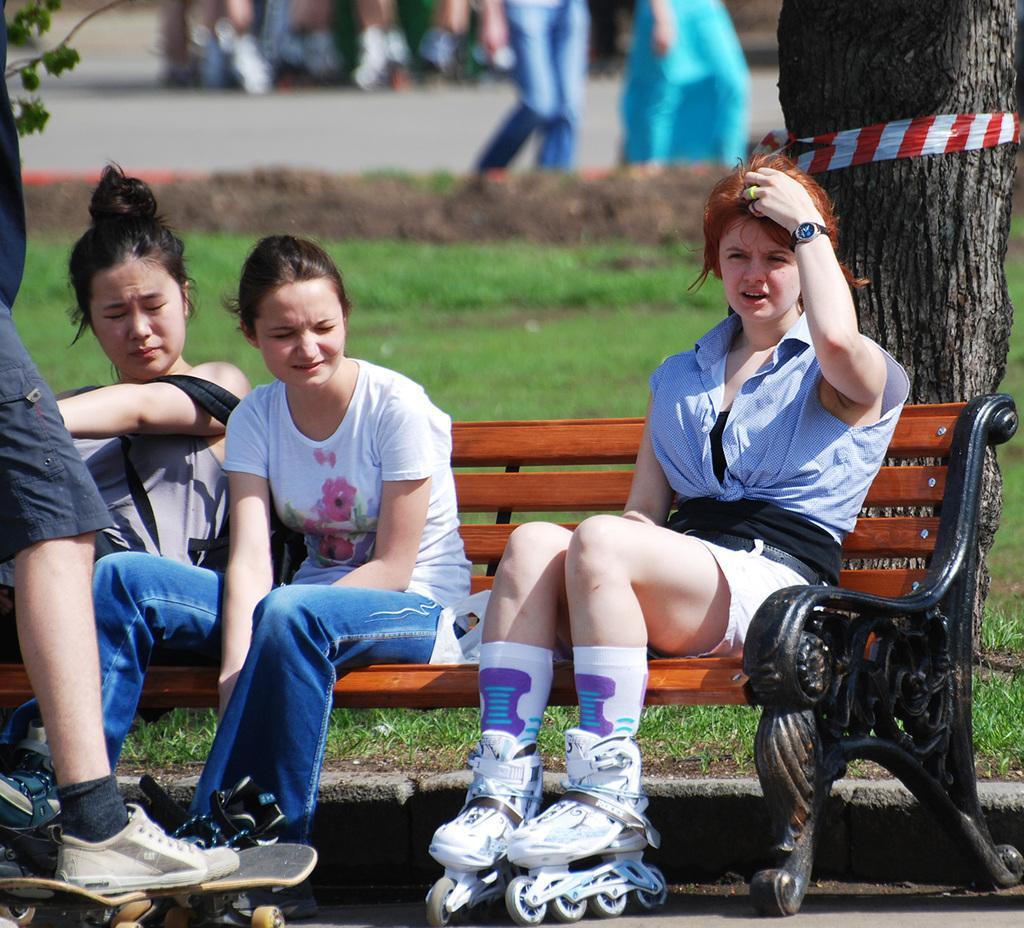Describe this image in one or two sentences. In this picture we can see there are three women sitting on a bench and a person is standing on the skateboard. Behind the people there is a tree trunk and some blurred things. 